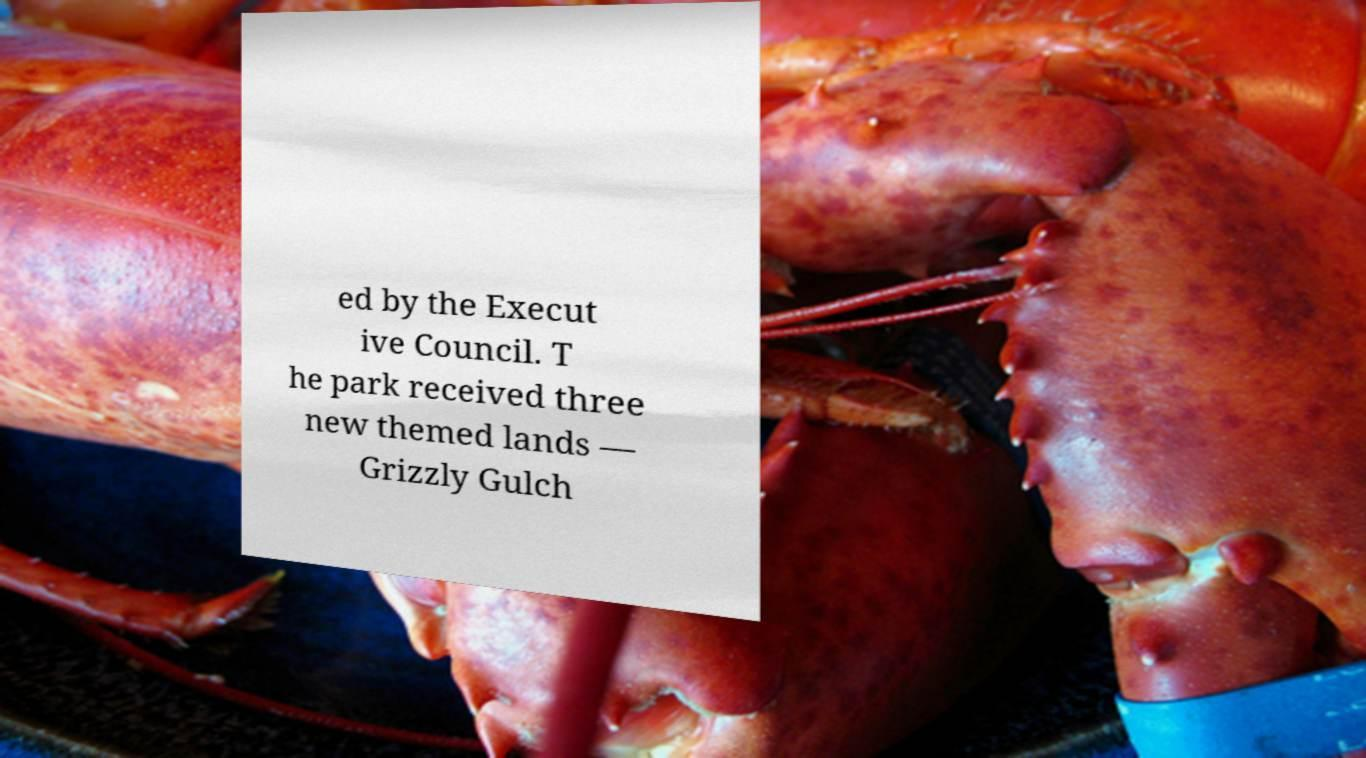Can you accurately transcribe the text from the provided image for me? ed by the Execut ive Council. T he park received three new themed lands — Grizzly Gulch 